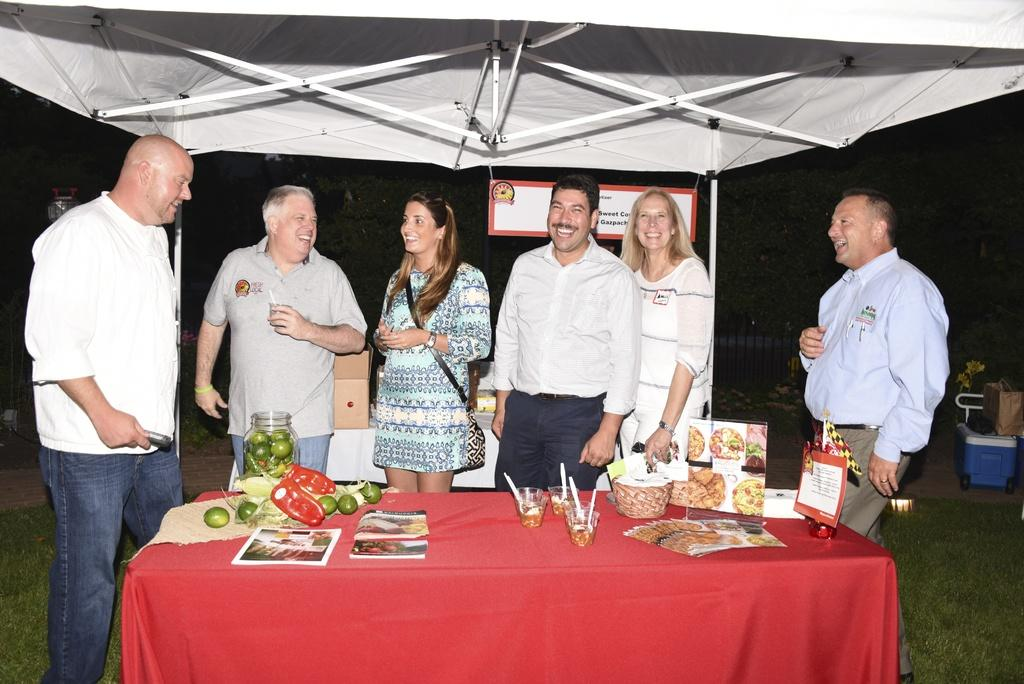How many people are in the image? There are 6 persons in the image. What are the persons doing in the image? The persons are standing around a table and laughing. What is on the table in the image? There are food items on the table. What type of peace treaty is being signed on the table in the image? There is no peace treaty or any indication of signing in the image; the persons are standing around the table and laughing. How many kittens are present on the table in the image? There are no kittens present in the image; the table has food items on it. 